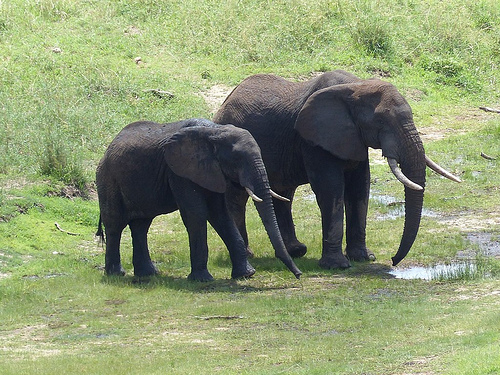What are the elephants standing on? The elephants are standing on a grassy and muddy area, with some patches of water visible. Can you see any other animals in the vicinity? No other animals are visible in the immediate vicinity of the elephants. Describe the environment in detail. The environment is a lush, grassy area with patches of mud and water. The ground appears slightly uneven, and the grass seems to be thriving, indicating a healthy ecosystem. The area looks like it might be part of a larger savanna or grassland, typical of regions where elephants reside. The light and shadows suggest it is a sunny day, adding to the vibrancy of the green grass and the overall natural beauty of the scene. If you were an elephant, what might you be thinking or feeling in this environment? As an elephant, I might be feeling content and secure in this lush environment. The abundance of grass provides ample food, and the presence of water ensures I stay hydrated. The open space allows me to roam freely and socialize with other elephants in my herd, contributing to a sense of community and well-being. 